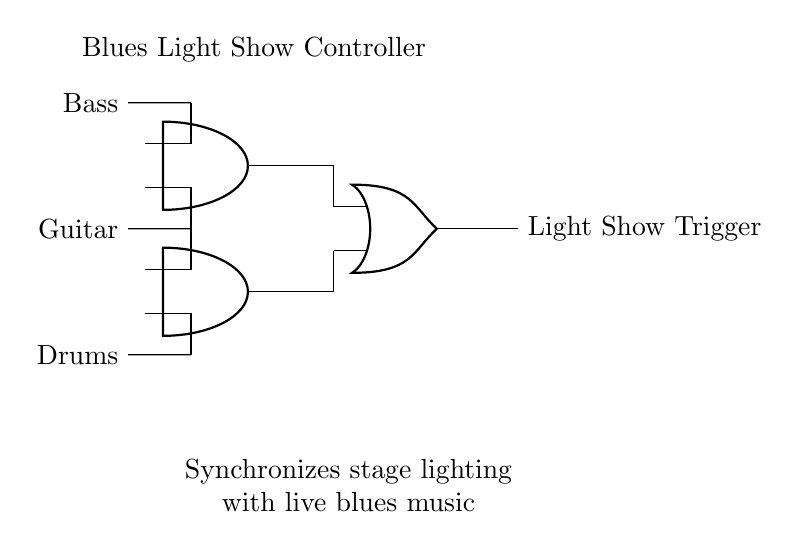What are the three input signals in the circuit? The circuit diagram shows three input signals: Bass, Guitar, and Drums. These are labeled next to the corresponding points in the circuit.
Answer: Bass, Guitar, Drums How many AND gates are present in the circuit? The diagram illustrates two AND gates indicated by their symbols. They are labeled at coordinates (2,4) and (2,2).
Answer: 2 What type of gate is used to combine the outputs of the AND gates? The circuit uses an OR gate to combine the outputs. This is clearly depicted in the diagram with the appropriate gate symbol, located at (5,3).
Answer: OR gate What is the output of the circuit labeled as? The output of the circuit is labeled as "Light Show Trigger", which is indicated clearly to the right of the OR gate output in the diagram.
Answer: Light Show Trigger Which signals are fed into the first AND gate? The first AND gate receives the Bass and Guitar signals, as shown by the connections leading into it from the respective input signals in the diagram.
Answer: Bass, Guitar What would happen if only one input signal is active for the second AND gate? If only one input signal is active at the second AND gate, it will not trigger an output because the AND gate requires both inputs to be true (active) to produce a true output.
Answer: No output 